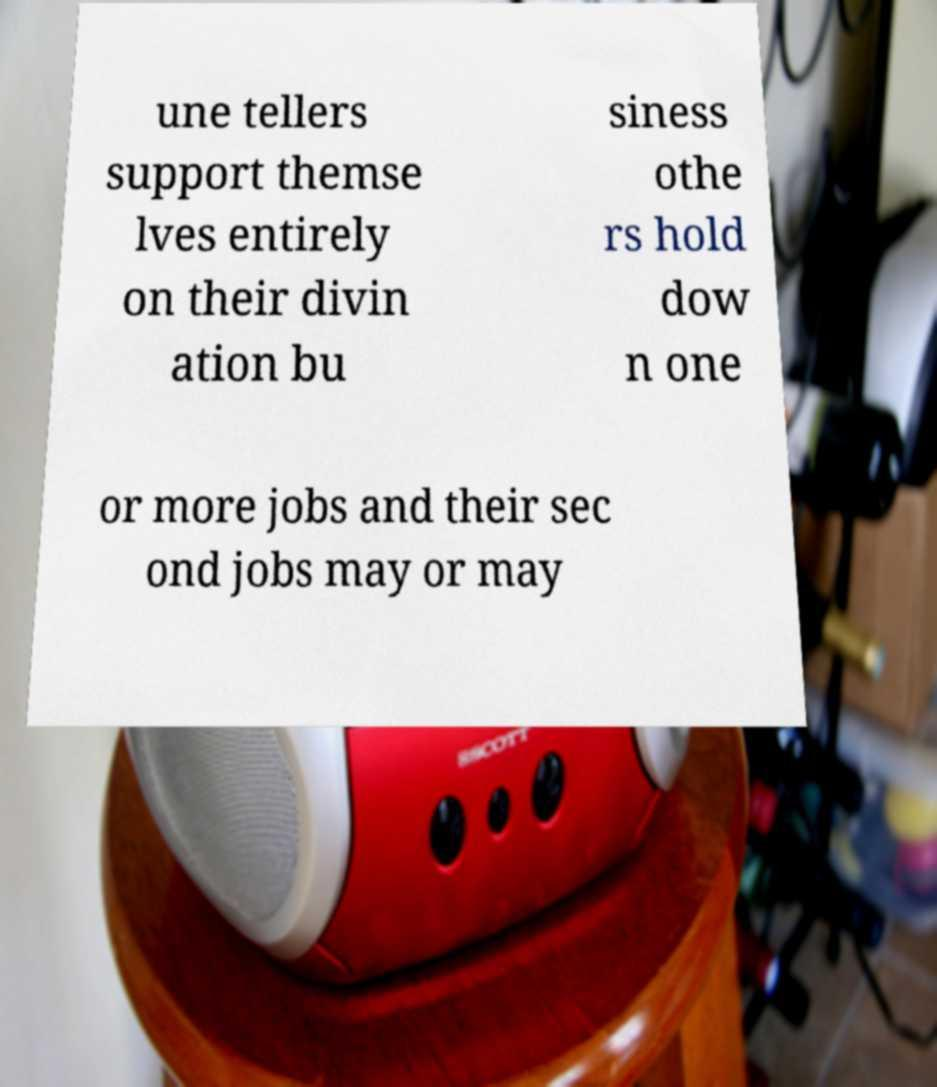Can you accurately transcribe the text from the provided image for me? une tellers support themse lves entirely on their divin ation bu siness othe rs hold dow n one or more jobs and their sec ond jobs may or may 